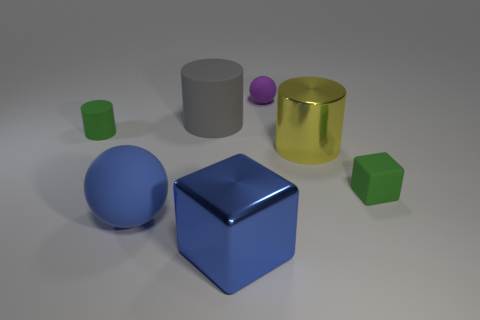What do the different shapes in the picture remind you of? The varying geometric shapes may evoke different associations. The blue sphere could resemble a planet, the block might remind one of building blocks, the cylinder could be seen as a column or a canister, while the smaller cube and sphere might bring to mind dice or marbles, embodying principles of simplicity and fundamental geometry. 